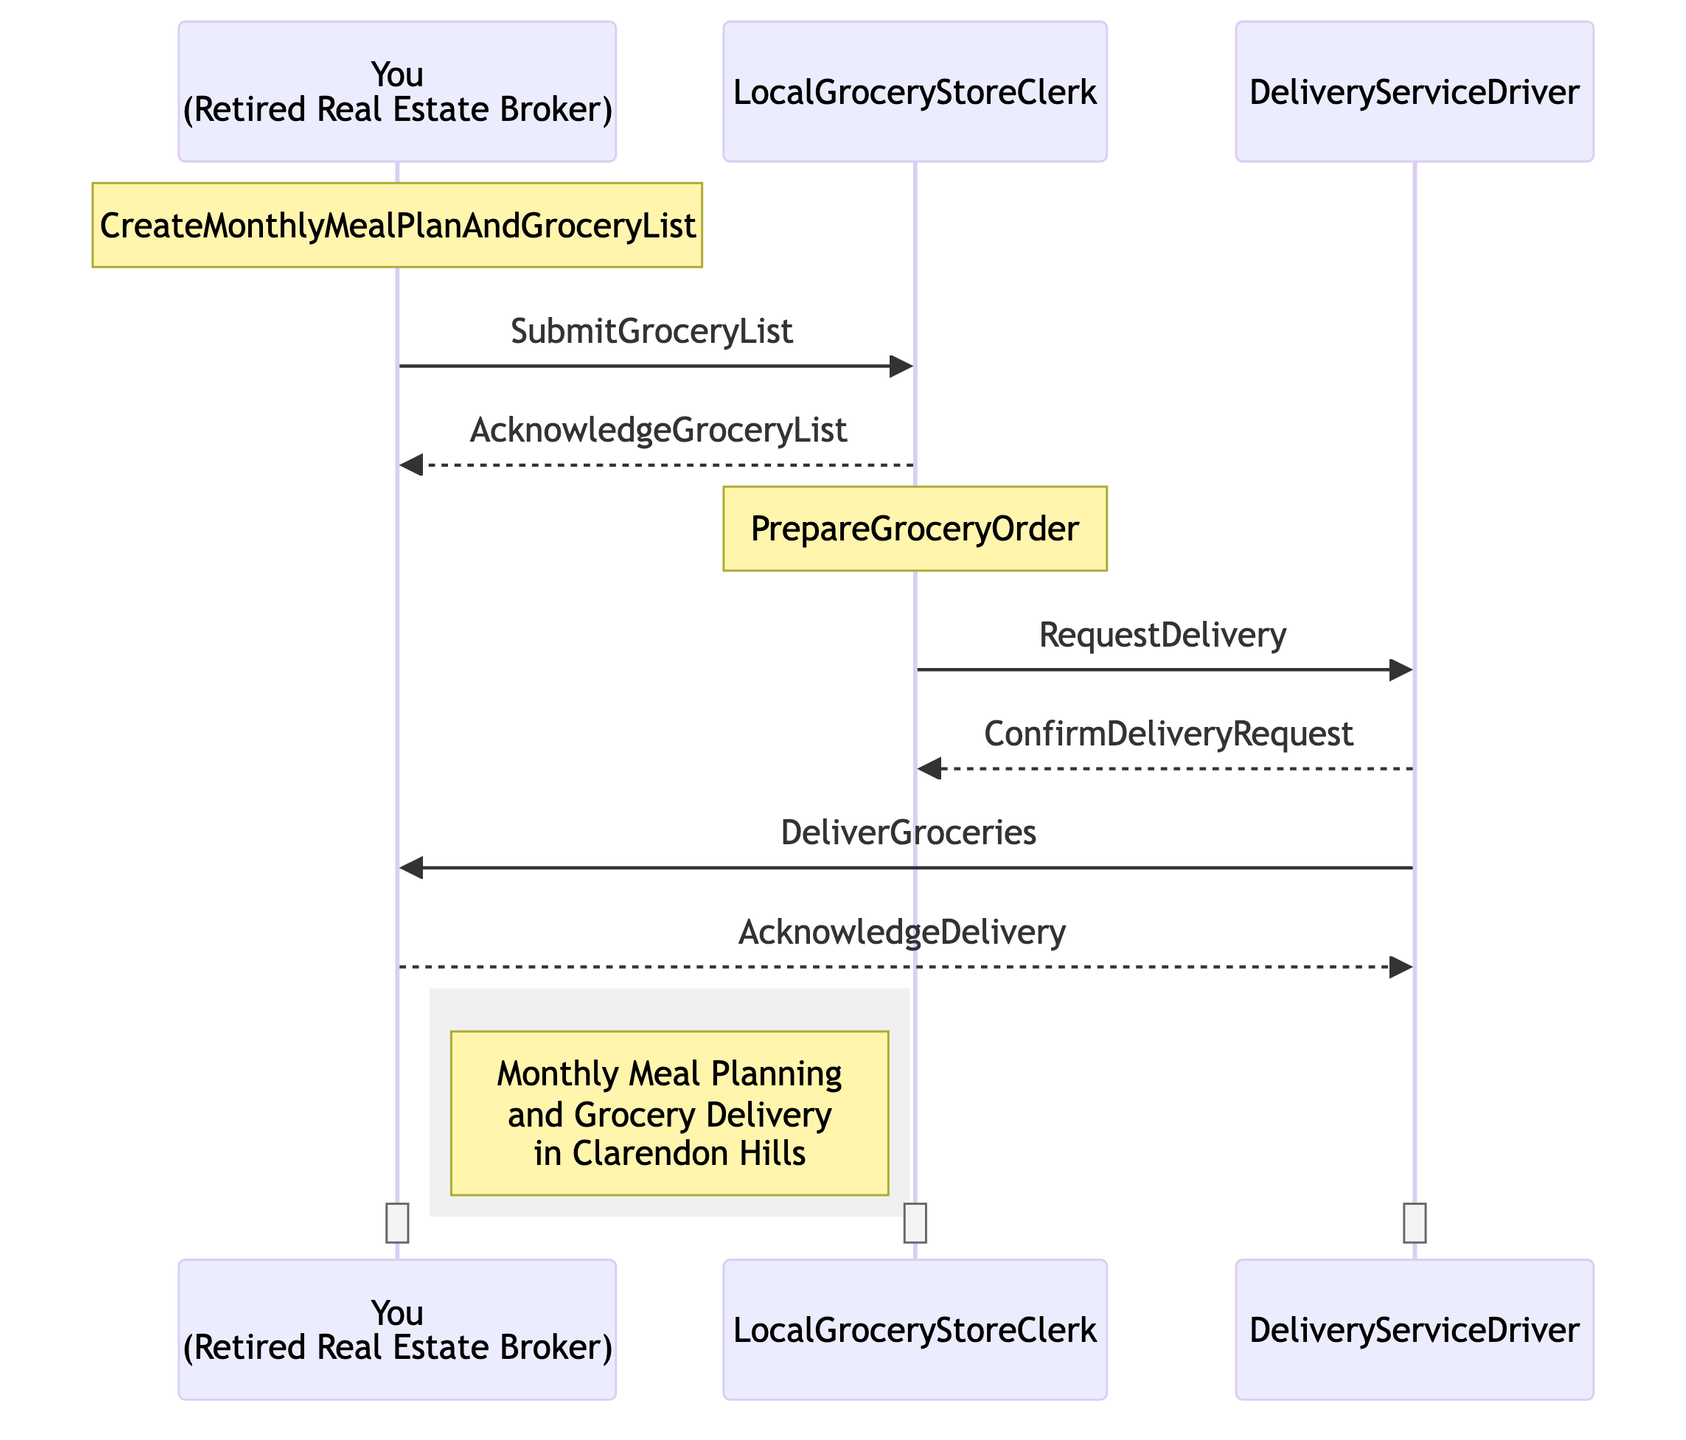What is the first action you take in the sequence? The first action is "CreateMonthlyMealPlanAndGroceryList," where you create your meal plan and grocery list.
Answer: CreateMonthlyMealPlanAndGroceryList Who do you submit your grocery list to? You submit the grocery list to the "LocalGroceryStoreClerk."
Answer: LocalGroceryStoreClerk How many messages are sent from the Local Grocery Store Clerk? The Local Grocery Store Clerk sends two messages: "AcknowledgeGroceryList" back to you, and "RequestDelivery" to the Delivery Service Driver.
Answer: Two What does the Delivery Service Driver confirm? The Delivery Service Driver confirms the delivery request with the message "ConfirmDeliveryRequest."
Answer: ConfirmDeliveryRequest What is the final interaction you have in the sequence? The final interaction is "AcknowledgeDelivery," where you confirm that you've received the groceries.
Answer: AcknowledgeDelivery What document or list do you create before submitting it to the grocery store? You create a "grocery list" based on your meal plan.
Answer: Grocery list What does the Local Grocery Store Clerk do after acknowledging your list? After acknowledging your list, the clerk prepares the grocery order.
Answer: PrepareGroceryOrder How is the grocery order delivered to you? The grocery order is delivered to you by the Delivery Service Driver.
Answer: DeliverGroceries What activity occurs in the local grocery store that doesn't directly involve you? The activity is "PrepareGroceryOrder," which is done by the Local Grocery Store Clerk.
Answer: PrepareGroceryOrder 